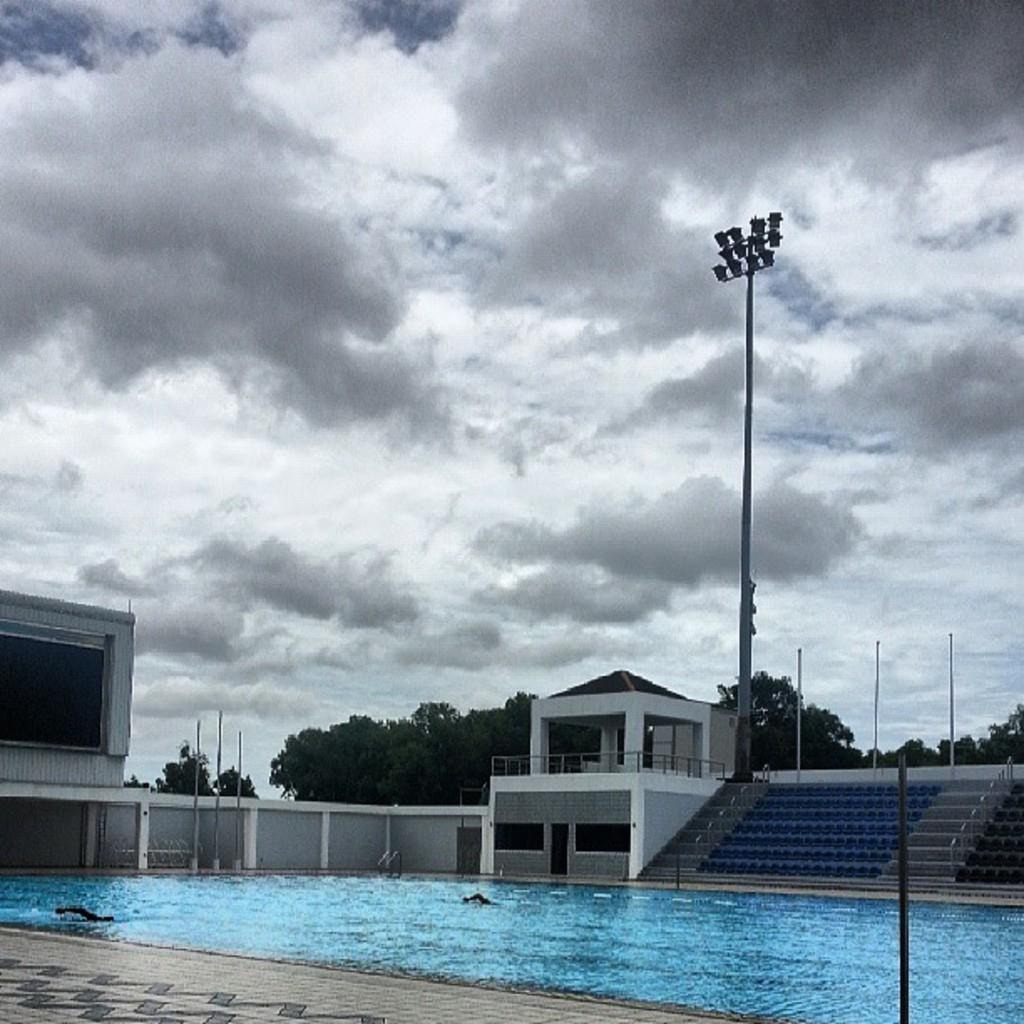What type of vegetation can be seen in the image? There are trees in the image. What type of structure is present in the image? There is a building in the image. What is the tall, cylindrical object with a light on top in the image? There is a light pole in the image. What are the long, thin objects supporting the wires in the image? There are poles in the image. What can be seen flowing or covering the ground in the image? There is water visible in the image. What architectural feature allows access to different levels in the image? There are stairs in the image. What is the color of the sky in the image? The sky is white in color. Can you tell me how many bears are sitting on the stairs in the image? There are no bears present in the image; it features trees, a building, a light pole, poles, water, stairs, and a white sky. What part of the image is ordered alphabetically? The image does not have any elements that are ordered alphabetically. 